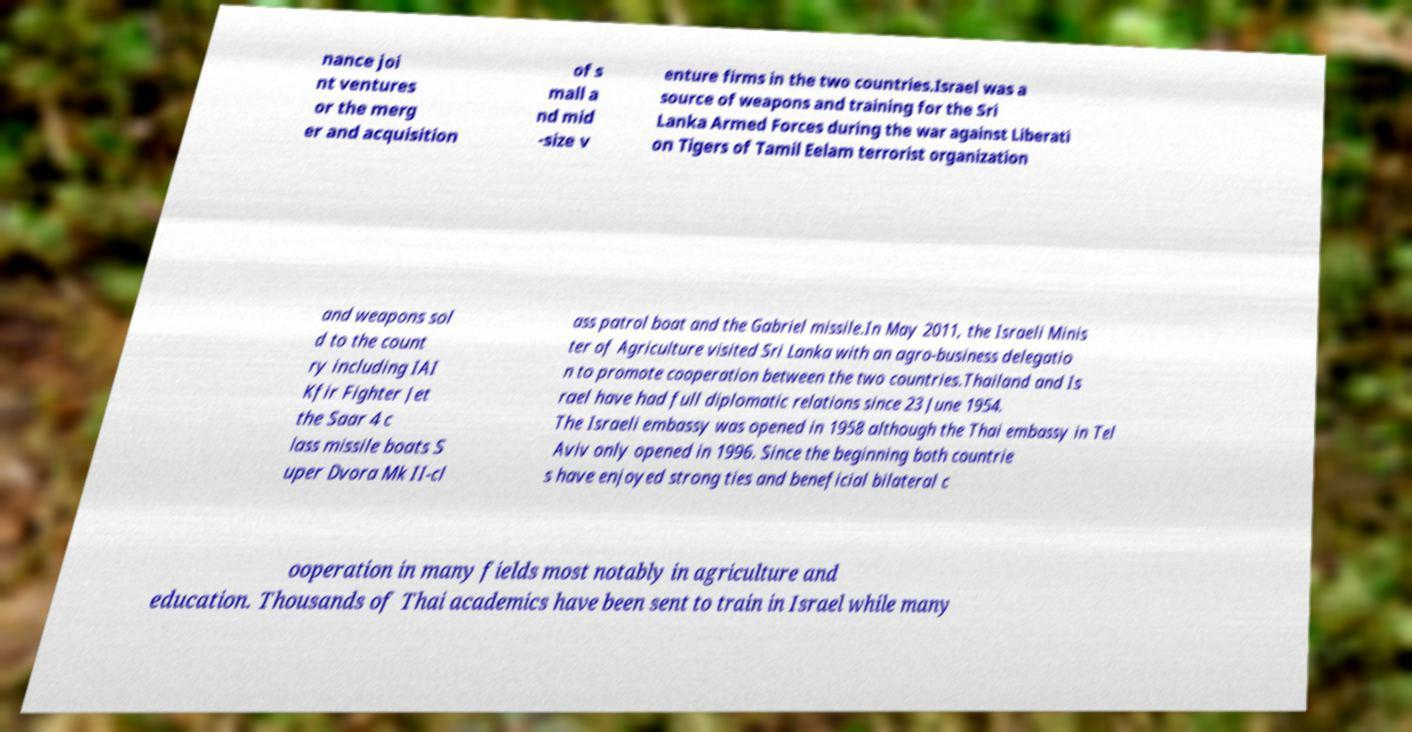Please identify and transcribe the text found in this image. nance joi nt ventures or the merg er and acquisition of s mall a nd mid -size v enture firms in the two countries.Israel was a source of weapons and training for the Sri Lanka Armed Forces during the war against Liberati on Tigers of Tamil Eelam terrorist organization and weapons sol d to the count ry including IAI Kfir Fighter Jet the Saar 4 c lass missile boats S uper Dvora Mk II-cl ass patrol boat and the Gabriel missile.In May 2011, the Israeli Minis ter of Agriculture visited Sri Lanka with an agro-business delegatio n to promote cooperation between the two countries.Thailand and Is rael have had full diplomatic relations since 23 June 1954. The Israeli embassy was opened in 1958 although the Thai embassy in Tel Aviv only opened in 1996. Since the beginning both countrie s have enjoyed strong ties and beneficial bilateral c ooperation in many fields most notably in agriculture and education. Thousands of Thai academics have been sent to train in Israel while many 